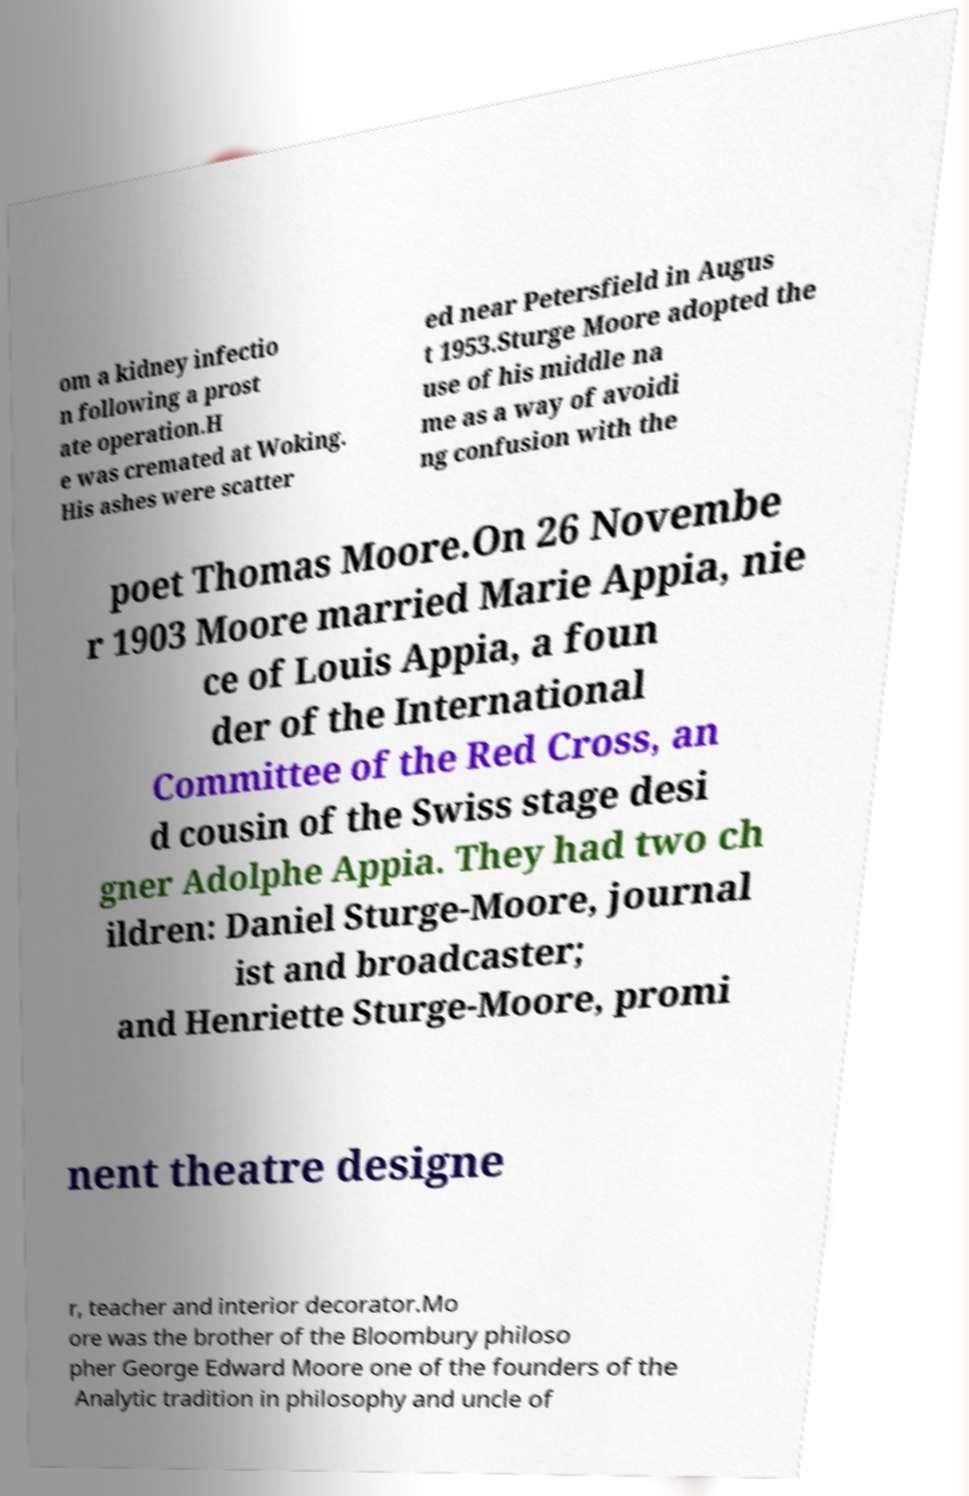For documentation purposes, I need the text within this image transcribed. Could you provide that? om a kidney infectio n following a prost ate operation.H e was cremated at Woking. His ashes were scatter ed near Petersfield in Augus t 1953.Sturge Moore adopted the use of his middle na me as a way of avoidi ng confusion with the poet Thomas Moore.On 26 Novembe r 1903 Moore married Marie Appia, nie ce of Louis Appia, a foun der of the International Committee of the Red Cross, an d cousin of the Swiss stage desi gner Adolphe Appia. They had two ch ildren: Daniel Sturge-Moore, journal ist and broadcaster; and Henriette Sturge-Moore, promi nent theatre designe r, teacher and interior decorator.Mo ore was the brother of the Bloombury philoso pher George Edward Moore one of the founders of the Analytic tradition in philosophy and uncle of 